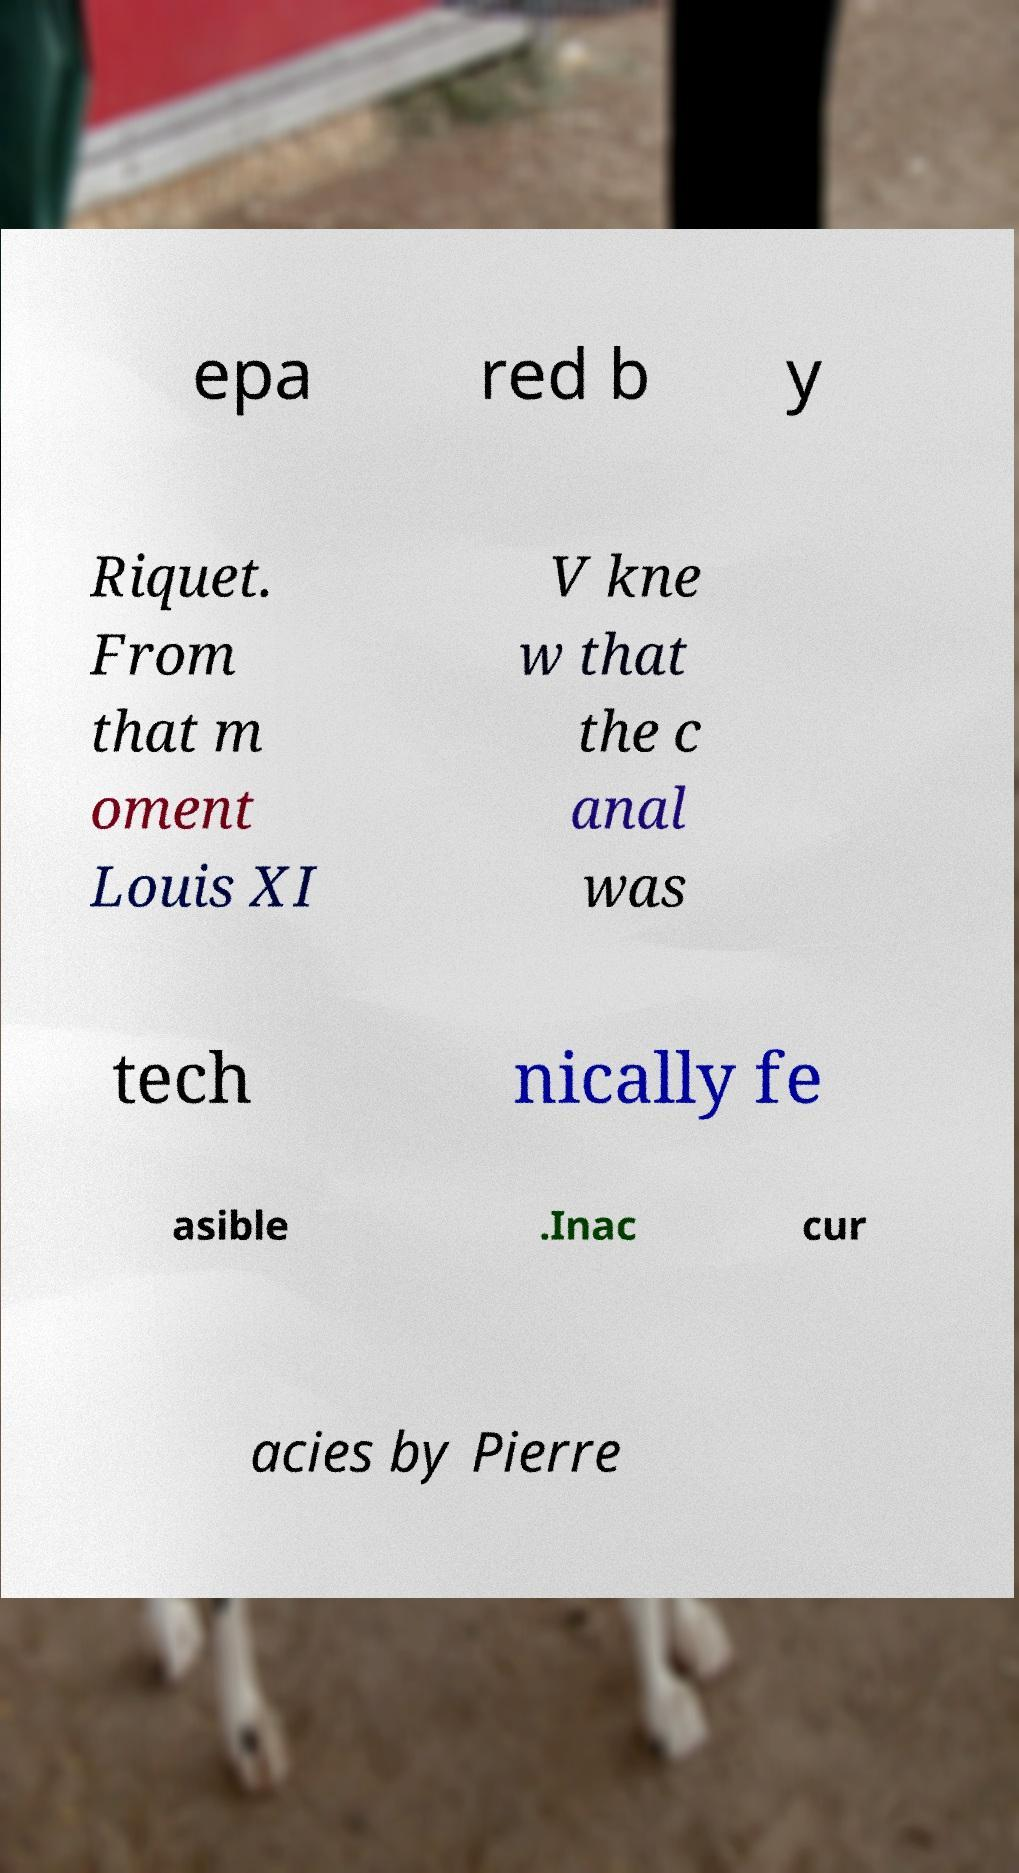Can you accurately transcribe the text from the provided image for me? epa red b y Riquet. From that m oment Louis XI V kne w that the c anal was tech nically fe asible .Inac cur acies by Pierre 